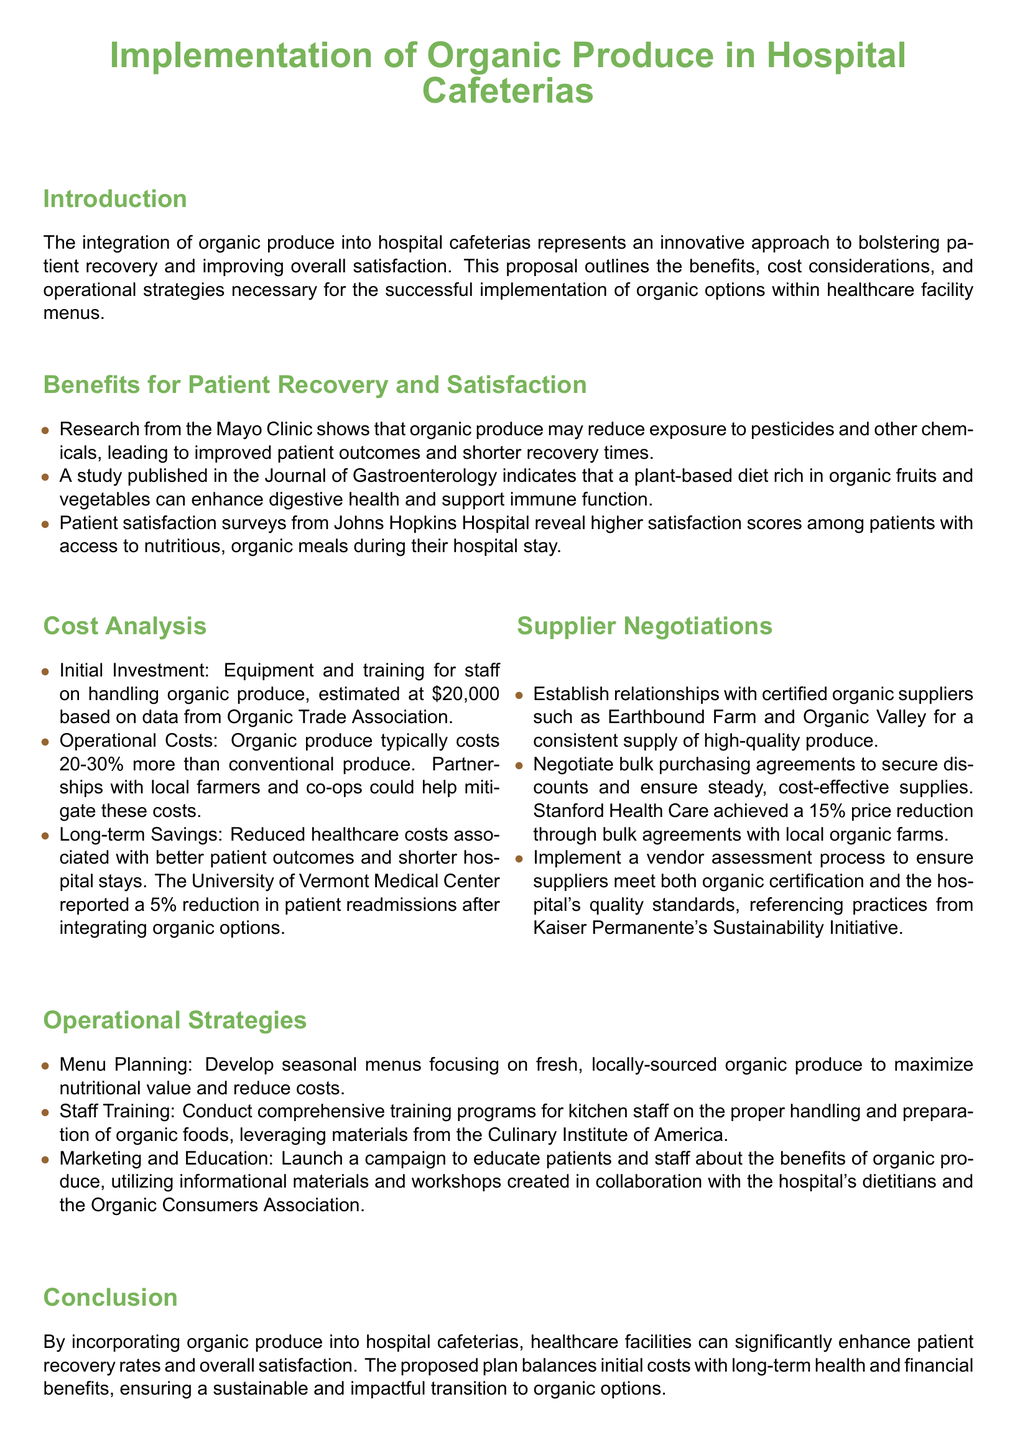what is the initial investment for organic implementation? The document states that the initial investment for equipment and training is estimated at $20,000.
Answer: $20,000 what percentage more does organic produce typically cost? The operational costs section mentions that organic produce typically costs 20-30% more than conventional produce.
Answer: 20-30% which hospital reported a 5% reduction in patient readmissions? The proposal cites the University of Vermont Medical Center as the institution that reported this reduction after integrating organic options.
Answer: University of Vermont Medical Center who are suggested certified organic suppliers? The document lists Earthbound Farm and Organic Valley as suggested suppliers for a consistent supply of organic produce.
Answer: Earthbound Farm and Organic Valley what is the main benefit of organic produce according to the Mayo Clinic? The document notes that research from the Mayo Clinic shows that organic produce may reduce exposure to pesticides and other chemicals, leading to improved patient outcomes.
Answer: Improved patient outcomes what type of negotiation is recommended for securing discounts? The supplier negotiations section emphasizes the importance of negotiating bulk purchasing agreements to secure discounts.
Answer: Bulk purchasing agreements what should be included in staff training? The document states that training programs should cover the proper handling and preparation of organic foods.
Answer: Proper handling and preparation of organic foods what campaign is suggested to promote organic produce? According to the operational strategies section, it suggests launching a campaign to educate patients and staff about the benefits of organic produce.
Answer: Education campaign what is a key factor in operational strategies for menu planning? The proposal emphasizes developing seasonal menus focusing on fresh, locally-sourced organic produce.
Answer: Seasonal menus focusing on fresh, locally-sourced organic produce 